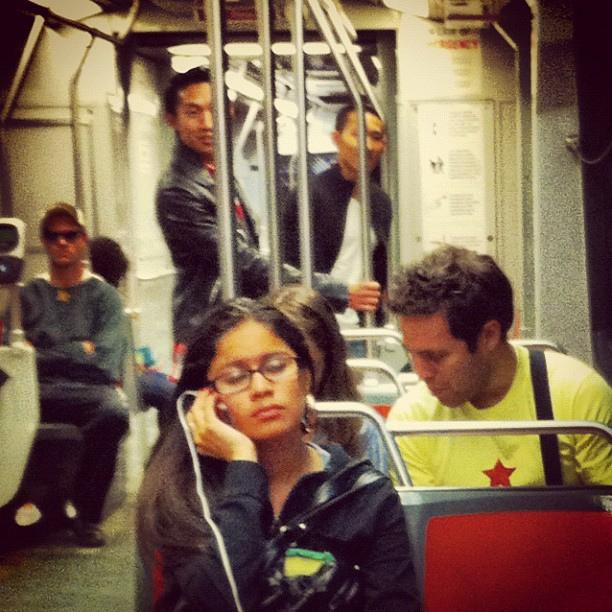Are these people on public transportation?
Short answer required. Yes. Are all the passengers guys?
Give a very brief answer. No. Is the woman sleeping?
Short answer required. No. 